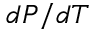<formula> <loc_0><loc_0><loc_500><loc_500>d P / d T</formula> 